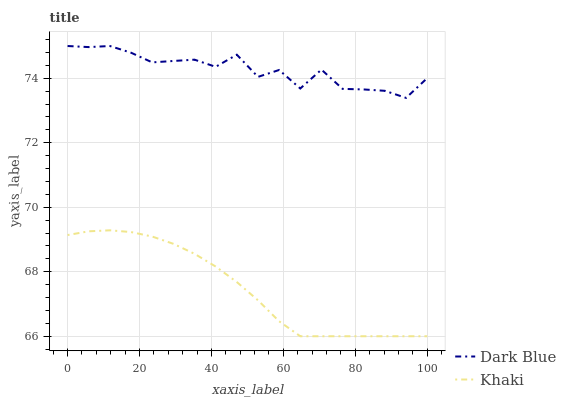Does Khaki have the minimum area under the curve?
Answer yes or no. Yes. Does Dark Blue have the maximum area under the curve?
Answer yes or no. Yes. Does Khaki have the maximum area under the curve?
Answer yes or no. No. Is Khaki the smoothest?
Answer yes or no. Yes. Is Dark Blue the roughest?
Answer yes or no. Yes. Is Khaki the roughest?
Answer yes or no. No. Does Dark Blue have the highest value?
Answer yes or no. Yes. Does Khaki have the highest value?
Answer yes or no. No. Is Khaki less than Dark Blue?
Answer yes or no. Yes. Is Dark Blue greater than Khaki?
Answer yes or no. Yes. Does Khaki intersect Dark Blue?
Answer yes or no. No. 